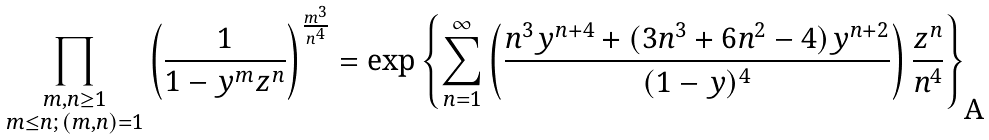<formula> <loc_0><loc_0><loc_500><loc_500>\prod _ { \substack { m , n \geq 1 \\ m \leq n ; \, ( m , n ) = 1 } } \left ( \frac { 1 } { 1 - y ^ { m } z ^ { n } } \right ) ^ { \frac { m ^ { 3 } } { n ^ { 4 } } } = \exp \left \{ \sum _ { n = 1 } ^ { \infty } \left ( \frac { n ^ { 3 } y ^ { n + 4 } + ( 3 n ^ { 3 } + 6 n ^ { 2 } - 4 ) y ^ { n + 2 } } { ( 1 - y ) ^ { 4 } } \right ) \frac { z ^ { n } } { n ^ { 4 } } \right \}</formula> 